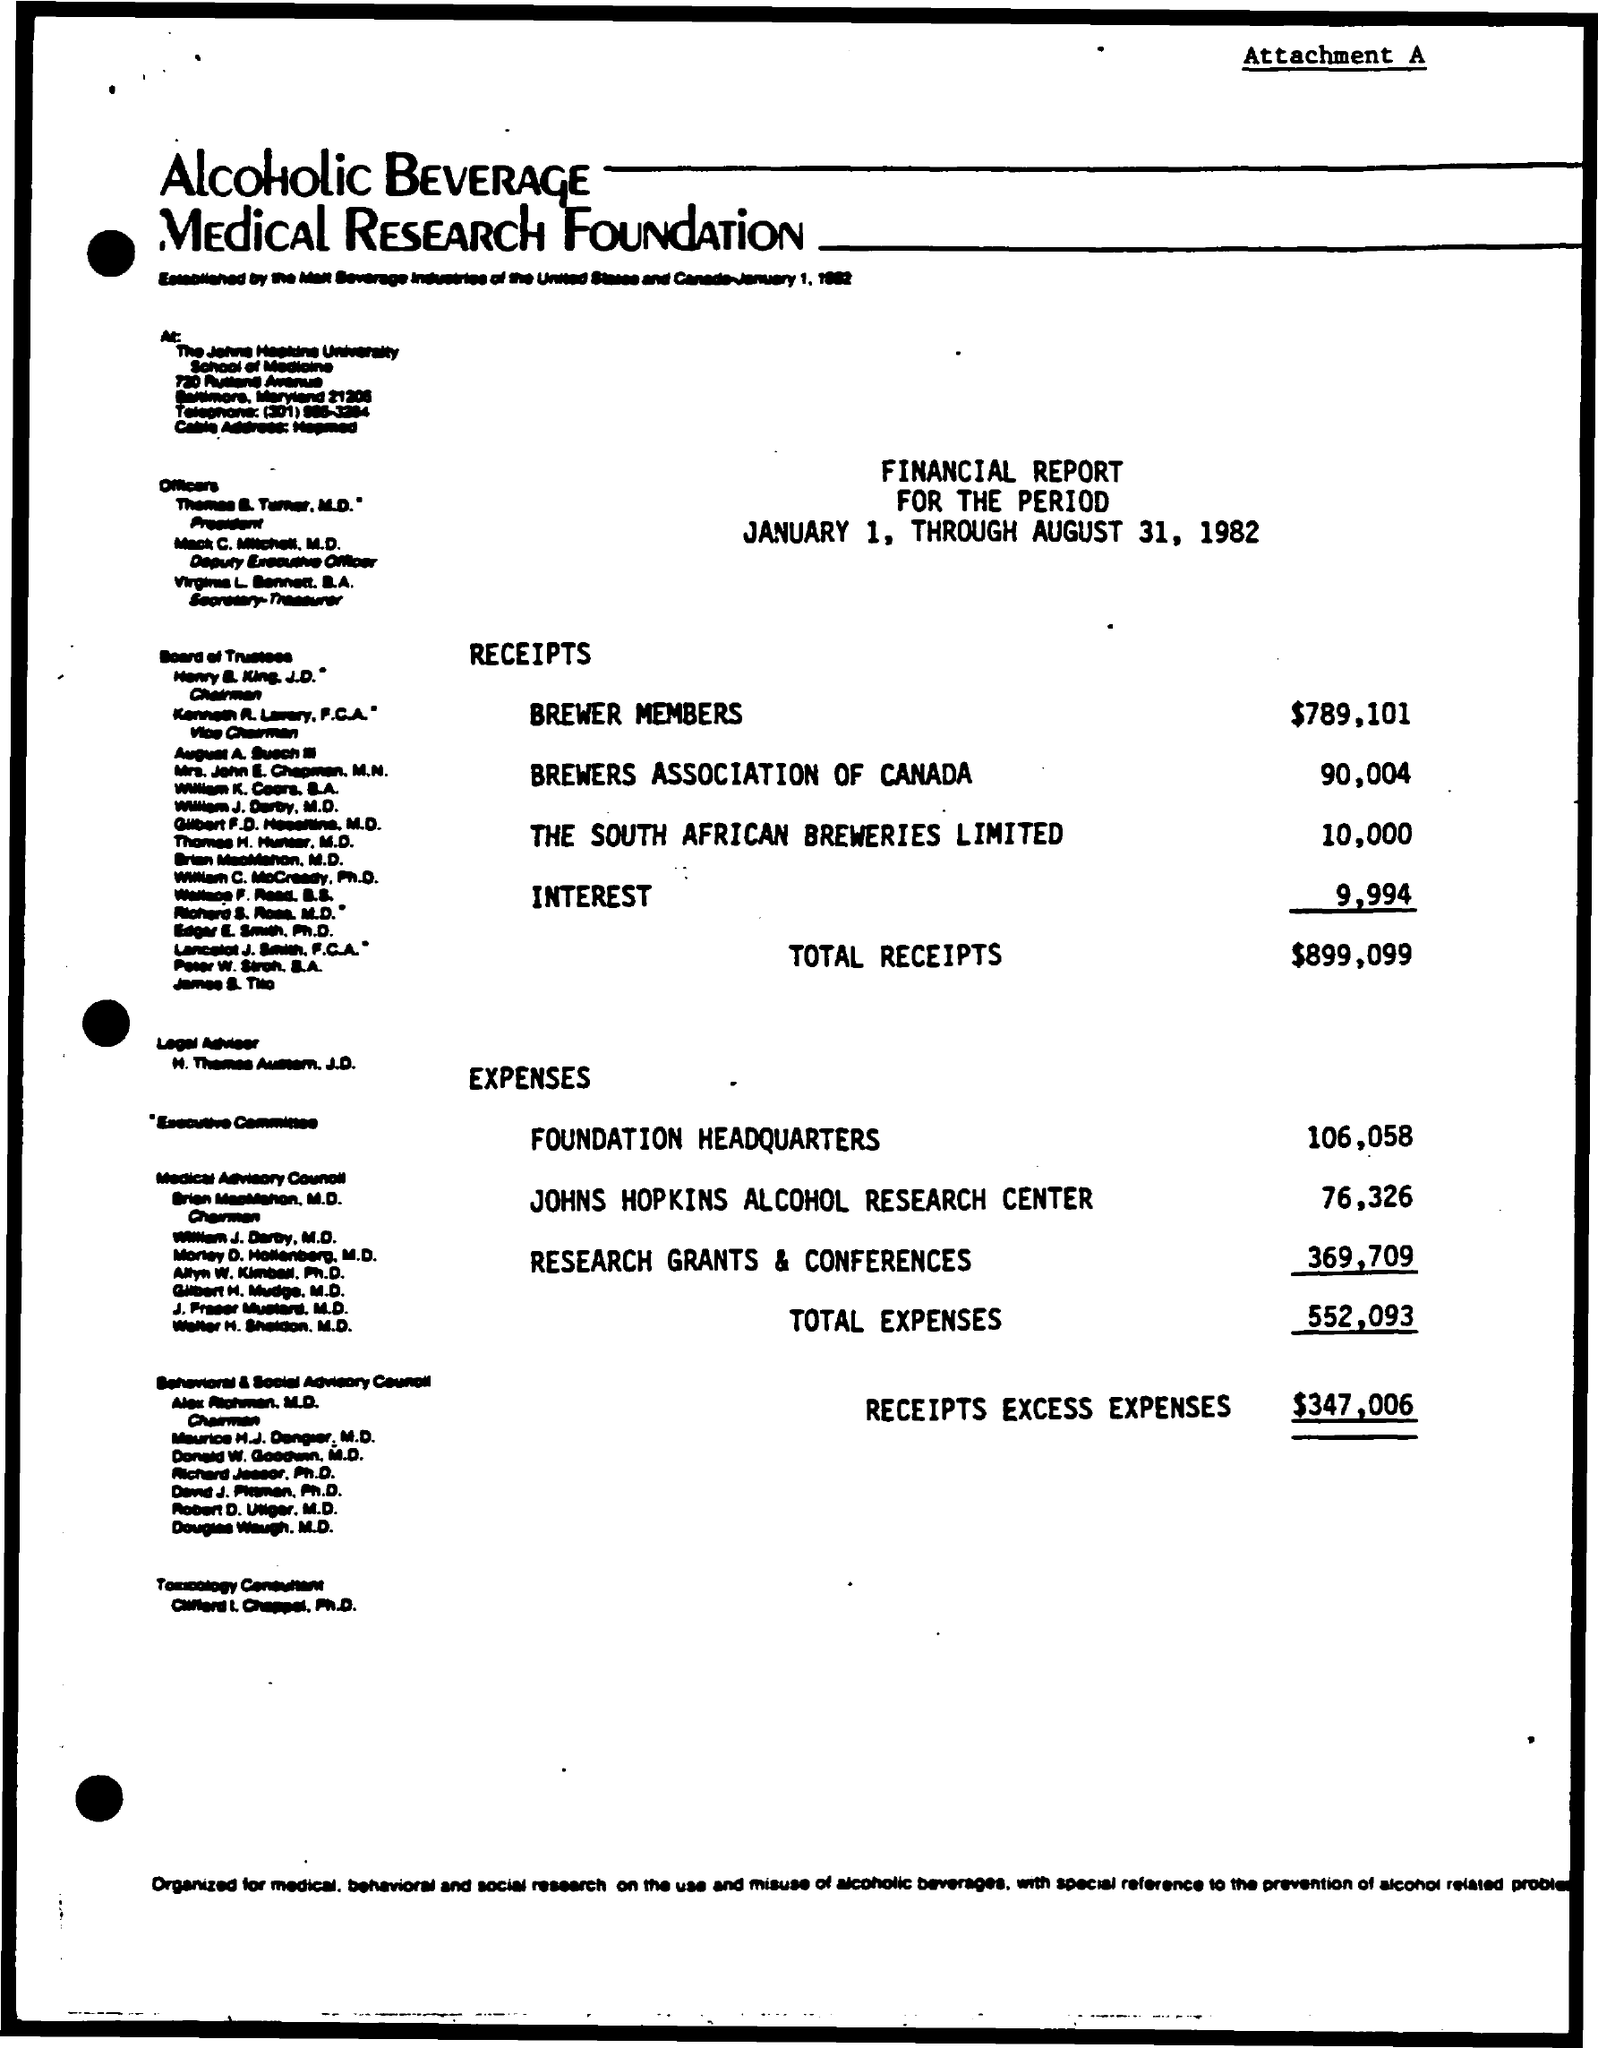Identify some key points in this picture. The expenses for the foundation headquarters are 106,058. The amount for the Brewer Association of Canada is $90,004. The amount for Brewer members is $789,101. The total expenses amount to 552,093. The expenses for research grants and conferences are 369,709. 